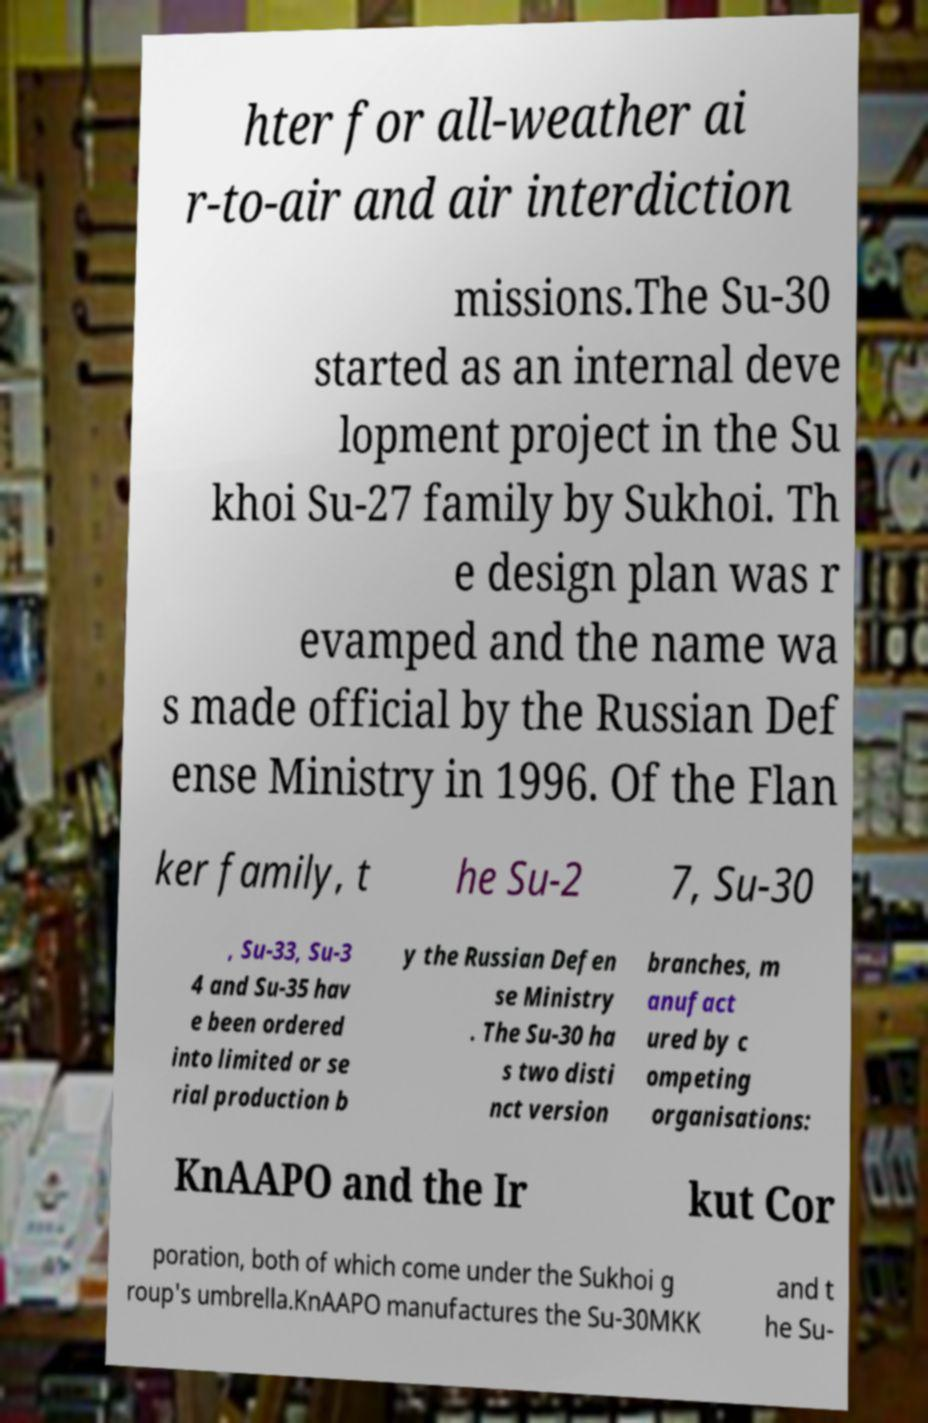What messages or text are displayed in this image? I need them in a readable, typed format. hter for all-weather ai r-to-air and air interdiction missions.The Su-30 started as an internal deve lopment project in the Su khoi Su-27 family by Sukhoi. Th e design plan was r evamped and the name wa s made official by the Russian Def ense Ministry in 1996. Of the Flan ker family, t he Su-2 7, Su-30 , Su-33, Su-3 4 and Su-35 hav e been ordered into limited or se rial production b y the Russian Defen se Ministry . The Su-30 ha s two disti nct version branches, m anufact ured by c ompeting organisations: KnAAPO and the Ir kut Cor poration, both of which come under the Sukhoi g roup's umbrella.KnAAPO manufactures the Su-30MKK and t he Su- 